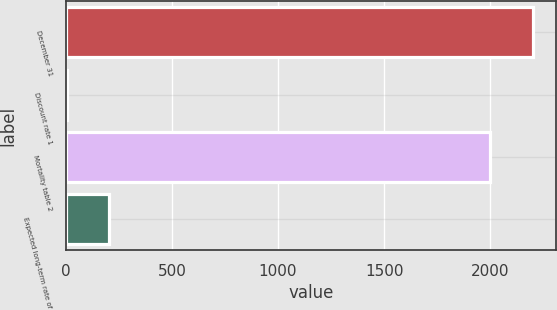Convert chart. <chart><loc_0><loc_0><loc_500><loc_500><bar_chart><fcel>December 31<fcel>Discount rate 1<fcel>Mortality table 2<fcel>Expected long-term rate of<nl><fcel>2200.61<fcel>4.9<fcel>2000<fcel>205.51<nl></chart> 